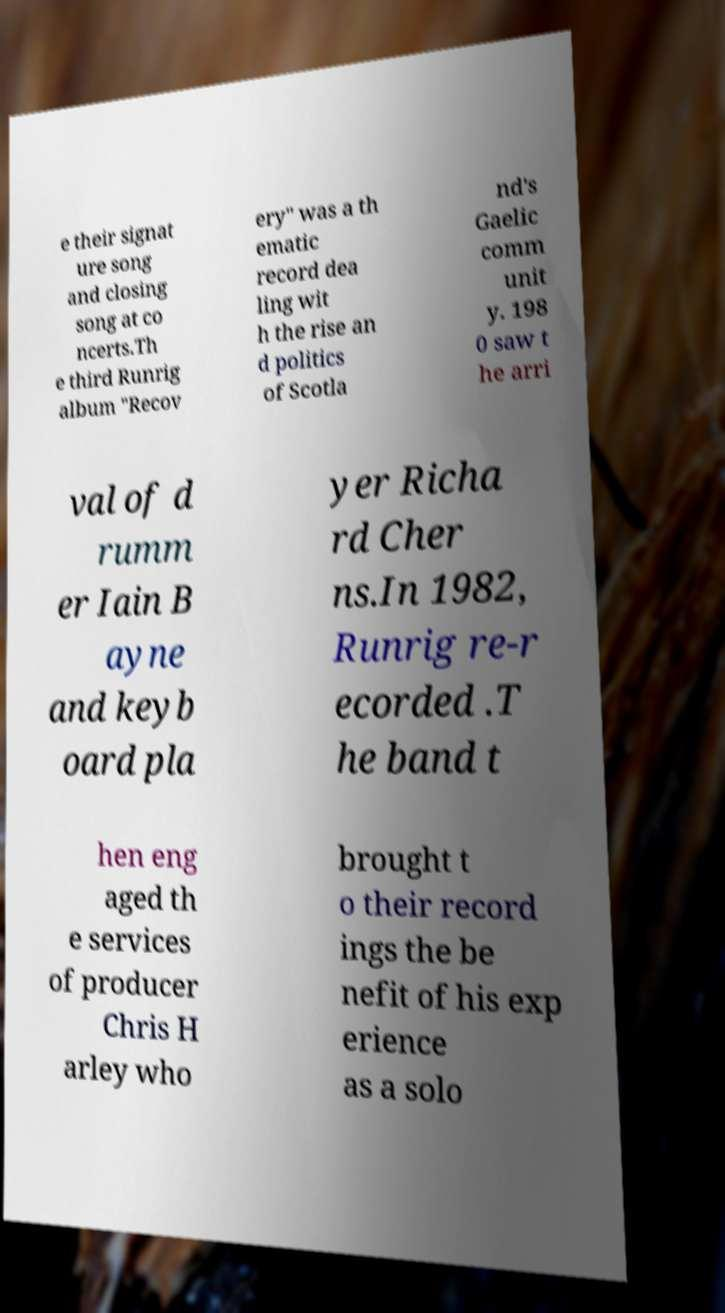Could you extract and type out the text from this image? e their signat ure song and closing song at co ncerts.Th e third Runrig album "Recov ery" was a th ematic record dea ling wit h the rise an d politics of Scotla nd's Gaelic comm unit y. 198 0 saw t he arri val of d rumm er Iain B ayne and keyb oard pla yer Richa rd Cher ns.In 1982, Runrig re-r ecorded .T he band t hen eng aged th e services of producer Chris H arley who brought t o their record ings the be nefit of his exp erience as a solo 